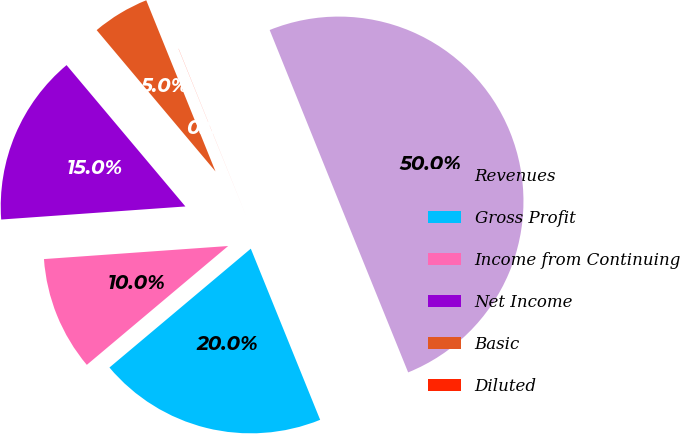Convert chart to OTSL. <chart><loc_0><loc_0><loc_500><loc_500><pie_chart><fcel>Revenues<fcel>Gross Profit<fcel>Income from Continuing<fcel>Net Income<fcel>Basic<fcel>Diluted<nl><fcel>49.98%<fcel>20.0%<fcel>10.0%<fcel>15.0%<fcel>5.01%<fcel>0.01%<nl></chart> 